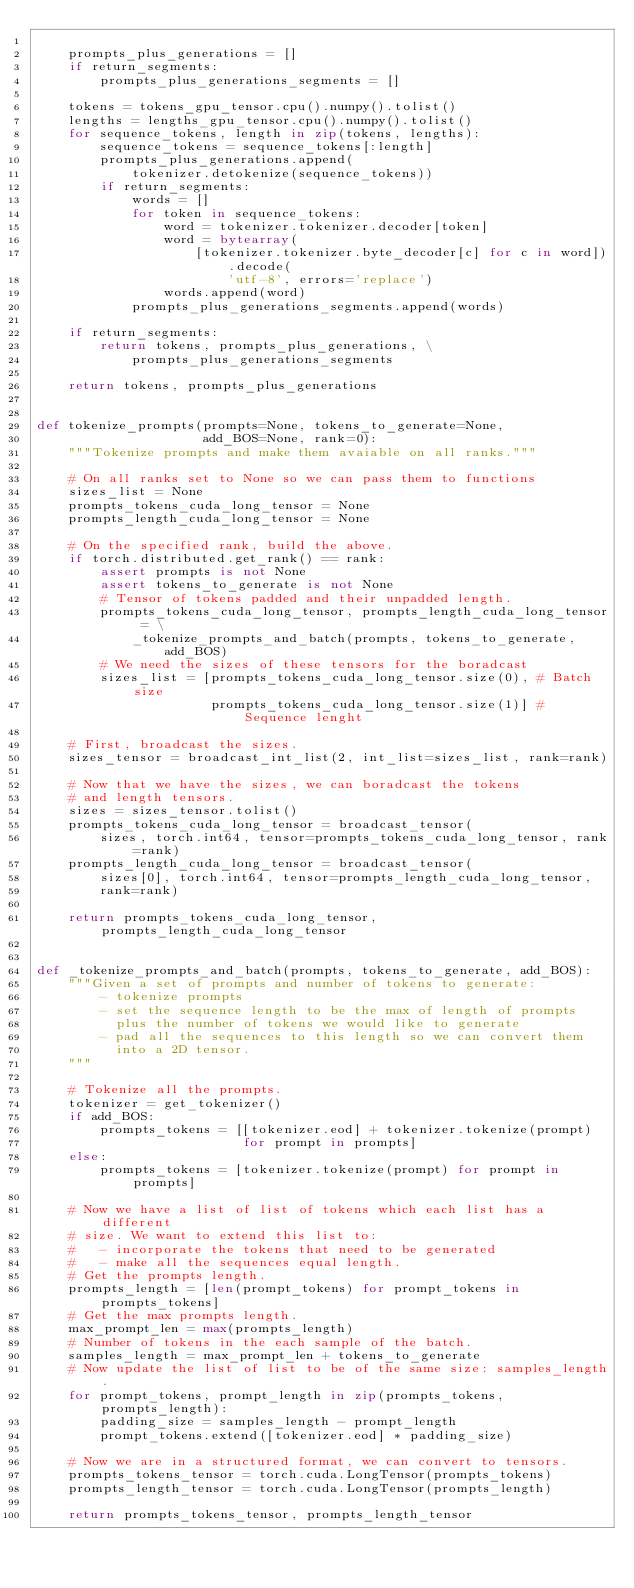Convert code to text. <code><loc_0><loc_0><loc_500><loc_500><_Python_>
    prompts_plus_generations = []
    if return_segments:
        prompts_plus_generations_segments = []

    tokens = tokens_gpu_tensor.cpu().numpy().tolist()
    lengths = lengths_gpu_tensor.cpu().numpy().tolist()
    for sequence_tokens, length in zip(tokens, lengths):
        sequence_tokens = sequence_tokens[:length]
        prompts_plus_generations.append(
            tokenizer.detokenize(sequence_tokens))
        if return_segments:
            words = []
            for token in sequence_tokens:
                word = tokenizer.tokenizer.decoder[token]
                word = bytearray(
                    [tokenizer.tokenizer.byte_decoder[c] for c in word]).decode(
                        'utf-8', errors='replace')
                words.append(word)
            prompts_plus_generations_segments.append(words)

    if return_segments:
        return tokens, prompts_plus_generations, \
            prompts_plus_generations_segments

    return tokens, prompts_plus_generations


def tokenize_prompts(prompts=None, tokens_to_generate=None,
                     add_BOS=None, rank=0):
    """Tokenize prompts and make them avaiable on all ranks."""

    # On all ranks set to None so we can pass them to functions
    sizes_list = None
    prompts_tokens_cuda_long_tensor = None
    prompts_length_cuda_long_tensor = None

    # On the specified rank, build the above.
    if torch.distributed.get_rank() == rank:
        assert prompts is not None
        assert tokens_to_generate is not None
        # Tensor of tokens padded and their unpadded length.
        prompts_tokens_cuda_long_tensor, prompts_length_cuda_long_tensor = \
            _tokenize_prompts_and_batch(prompts, tokens_to_generate, add_BOS)
        # We need the sizes of these tensors for the boradcast
        sizes_list = [prompts_tokens_cuda_long_tensor.size(0), # Batch size
                      prompts_tokens_cuda_long_tensor.size(1)] # Sequence lenght

    # First, broadcast the sizes.
    sizes_tensor = broadcast_int_list(2, int_list=sizes_list, rank=rank)

    # Now that we have the sizes, we can boradcast the tokens
    # and length tensors.
    sizes = sizes_tensor.tolist()
    prompts_tokens_cuda_long_tensor = broadcast_tensor(
        sizes, torch.int64, tensor=prompts_tokens_cuda_long_tensor, rank=rank)
    prompts_length_cuda_long_tensor = broadcast_tensor(
        sizes[0], torch.int64, tensor=prompts_length_cuda_long_tensor,
        rank=rank)

    return prompts_tokens_cuda_long_tensor, prompts_length_cuda_long_tensor


def _tokenize_prompts_and_batch(prompts, tokens_to_generate, add_BOS):
    """Given a set of prompts and number of tokens to generate:
        - tokenize prompts
        - set the sequence length to be the max of length of prompts
          plus the number of tokens we would like to generate
        - pad all the sequences to this length so we can convert them
          into a 2D tensor.
    """

    # Tokenize all the prompts.
    tokenizer = get_tokenizer()
    if add_BOS:
        prompts_tokens = [[tokenizer.eod] + tokenizer.tokenize(prompt)
                          for prompt in prompts]
    else:
        prompts_tokens = [tokenizer.tokenize(prompt) for prompt in prompts]

    # Now we have a list of list of tokens which each list has a different
    # size. We want to extend this list to:
    #   - incorporate the tokens that need to be generated
    #   - make all the sequences equal length.
    # Get the prompts length.
    prompts_length = [len(prompt_tokens) for prompt_tokens in prompts_tokens]
    # Get the max prompts length.
    max_prompt_len = max(prompts_length)
    # Number of tokens in the each sample of the batch.
    samples_length = max_prompt_len + tokens_to_generate
    # Now update the list of list to be of the same size: samples_length.
    for prompt_tokens, prompt_length in zip(prompts_tokens, prompts_length):
        padding_size = samples_length - prompt_length
        prompt_tokens.extend([tokenizer.eod] * padding_size)

    # Now we are in a structured format, we can convert to tensors.
    prompts_tokens_tensor = torch.cuda.LongTensor(prompts_tokens)
    prompts_length_tensor = torch.cuda.LongTensor(prompts_length)

    return prompts_tokens_tensor, prompts_length_tensor
</code> 